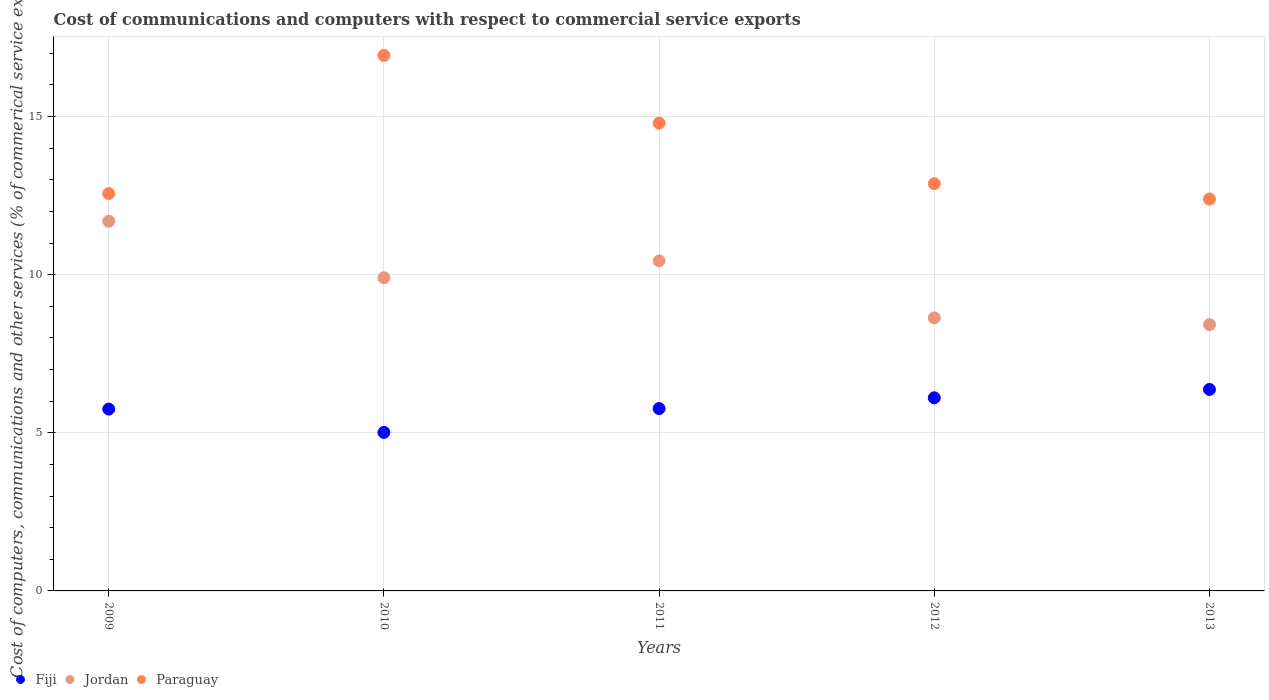Is the number of dotlines equal to the number of legend labels?
Your answer should be compact. Yes. What is the cost of communications and computers in Paraguay in 2009?
Keep it short and to the point. 12.56. Across all years, what is the maximum cost of communications and computers in Fiji?
Keep it short and to the point. 6.37. Across all years, what is the minimum cost of communications and computers in Fiji?
Make the answer very short. 5.01. In which year was the cost of communications and computers in Fiji maximum?
Make the answer very short. 2013. What is the total cost of communications and computers in Paraguay in the graph?
Offer a terse response. 69.56. What is the difference between the cost of communications and computers in Jordan in 2010 and that in 2011?
Make the answer very short. -0.53. What is the difference between the cost of communications and computers in Fiji in 2011 and the cost of communications and computers in Jordan in 2010?
Your answer should be compact. -4.14. What is the average cost of communications and computers in Fiji per year?
Make the answer very short. 5.8. In the year 2010, what is the difference between the cost of communications and computers in Paraguay and cost of communications and computers in Jordan?
Offer a terse response. 7.03. What is the ratio of the cost of communications and computers in Fiji in 2010 to that in 2013?
Your response must be concise. 0.79. Is the cost of communications and computers in Jordan in 2012 less than that in 2013?
Offer a terse response. No. Is the difference between the cost of communications and computers in Paraguay in 2010 and 2012 greater than the difference between the cost of communications and computers in Jordan in 2010 and 2012?
Your answer should be compact. Yes. What is the difference between the highest and the second highest cost of communications and computers in Paraguay?
Your answer should be compact. 2.14. What is the difference between the highest and the lowest cost of communications and computers in Fiji?
Your answer should be compact. 1.36. In how many years, is the cost of communications and computers in Fiji greater than the average cost of communications and computers in Fiji taken over all years?
Keep it short and to the point. 2. Is it the case that in every year, the sum of the cost of communications and computers in Paraguay and cost of communications and computers in Fiji  is greater than the cost of communications and computers in Jordan?
Offer a terse response. Yes. Is the cost of communications and computers in Paraguay strictly less than the cost of communications and computers in Jordan over the years?
Offer a very short reply. No. What is the difference between two consecutive major ticks on the Y-axis?
Ensure brevity in your answer.  5. Are the values on the major ticks of Y-axis written in scientific E-notation?
Make the answer very short. No. Does the graph contain grids?
Your answer should be very brief. Yes. Where does the legend appear in the graph?
Your answer should be very brief. Bottom left. How many legend labels are there?
Your answer should be very brief. 3. What is the title of the graph?
Provide a short and direct response. Cost of communications and computers with respect to commercial service exports. Does "Niger" appear as one of the legend labels in the graph?
Offer a terse response. No. What is the label or title of the X-axis?
Offer a terse response. Years. What is the label or title of the Y-axis?
Offer a very short reply. Cost of computers, communications and other services (% of commerical service exports). What is the Cost of computers, communications and other services (% of commerical service exports) of Fiji in 2009?
Your answer should be very brief. 5.75. What is the Cost of computers, communications and other services (% of commerical service exports) in Jordan in 2009?
Provide a short and direct response. 11.69. What is the Cost of computers, communications and other services (% of commerical service exports) in Paraguay in 2009?
Provide a succinct answer. 12.56. What is the Cost of computers, communications and other services (% of commerical service exports) of Fiji in 2010?
Your response must be concise. 5.01. What is the Cost of computers, communications and other services (% of commerical service exports) in Jordan in 2010?
Keep it short and to the point. 9.9. What is the Cost of computers, communications and other services (% of commerical service exports) in Paraguay in 2010?
Provide a succinct answer. 16.93. What is the Cost of computers, communications and other services (% of commerical service exports) in Fiji in 2011?
Offer a very short reply. 5.77. What is the Cost of computers, communications and other services (% of commerical service exports) in Jordan in 2011?
Ensure brevity in your answer.  10.44. What is the Cost of computers, communications and other services (% of commerical service exports) in Paraguay in 2011?
Give a very brief answer. 14.79. What is the Cost of computers, communications and other services (% of commerical service exports) of Fiji in 2012?
Your response must be concise. 6.11. What is the Cost of computers, communications and other services (% of commerical service exports) in Jordan in 2012?
Make the answer very short. 8.63. What is the Cost of computers, communications and other services (% of commerical service exports) in Paraguay in 2012?
Your response must be concise. 12.88. What is the Cost of computers, communications and other services (% of commerical service exports) of Fiji in 2013?
Give a very brief answer. 6.37. What is the Cost of computers, communications and other services (% of commerical service exports) in Jordan in 2013?
Give a very brief answer. 8.42. What is the Cost of computers, communications and other services (% of commerical service exports) in Paraguay in 2013?
Offer a very short reply. 12.39. Across all years, what is the maximum Cost of computers, communications and other services (% of commerical service exports) of Fiji?
Your response must be concise. 6.37. Across all years, what is the maximum Cost of computers, communications and other services (% of commerical service exports) of Jordan?
Your answer should be very brief. 11.69. Across all years, what is the maximum Cost of computers, communications and other services (% of commerical service exports) of Paraguay?
Give a very brief answer. 16.93. Across all years, what is the minimum Cost of computers, communications and other services (% of commerical service exports) in Fiji?
Ensure brevity in your answer.  5.01. Across all years, what is the minimum Cost of computers, communications and other services (% of commerical service exports) of Jordan?
Keep it short and to the point. 8.42. Across all years, what is the minimum Cost of computers, communications and other services (% of commerical service exports) of Paraguay?
Your answer should be very brief. 12.39. What is the total Cost of computers, communications and other services (% of commerical service exports) in Fiji in the graph?
Keep it short and to the point. 29.01. What is the total Cost of computers, communications and other services (% of commerical service exports) in Jordan in the graph?
Give a very brief answer. 49.08. What is the total Cost of computers, communications and other services (% of commerical service exports) of Paraguay in the graph?
Give a very brief answer. 69.56. What is the difference between the Cost of computers, communications and other services (% of commerical service exports) of Fiji in 2009 and that in 2010?
Give a very brief answer. 0.74. What is the difference between the Cost of computers, communications and other services (% of commerical service exports) in Jordan in 2009 and that in 2010?
Your answer should be very brief. 1.79. What is the difference between the Cost of computers, communications and other services (% of commerical service exports) in Paraguay in 2009 and that in 2010?
Give a very brief answer. -4.37. What is the difference between the Cost of computers, communications and other services (% of commerical service exports) of Fiji in 2009 and that in 2011?
Your answer should be compact. -0.02. What is the difference between the Cost of computers, communications and other services (% of commerical service exports) of Jordan in 2009 and that in 2011?
Provide a succinct answer. 1.25. What is the difference between the Cost of computers, communications and other services (% of commerical service exports) in Paraguay in 2009 and that in 2011?
Ensure brevity in your answer.  -2.23. What is the difference between the Cost of computers, communications and other services (% of commerical service exports) of Fiji in 2009 and that in 2012?
Keep it short and to the point. -0.36. What is the difference between the Cost of computers, communications and other services (% of commerical service exports) in Jordan in 2009 and that in 2012?
Offer a terse response. 3.06. What is the difference between the Cost of computers, communications and other services (% of commerical service exports) in Paraguay in 2009 and that in 2012?
Offer a very short reply. -0.31. What is the difference between the Cost of computers, communications and other services (% of commerical service exports) in Fiji in 2009 and that in 2013?
Your answer should be compact. -0.62. What is the difference between the Cost of computers, communications and other services (% of commerical service exports) in Jordan in 2009 and that in 2013?
Your response must be concise. 3.27. What is the difference between the Cost of computers, communications and other services (% of commerical service exports) of Paraguay in 2009 and that in 2013?
Your answer should be compact. 0.17. What is the difference between the Cost of computers, communications and other services (% of commerical service exports) of Fiji in 2010 and that in 2011?
Your answer should be compact. -0.76. What is the difference between the Cost of computers, communications and other services (% of commerical service exports) in Jordan in 2010 and that in 2011?
Keep it short and to the point. -0.53. What is the difference between the Cost of computers, communications and other services (% of commerical service exports) in Paraguay in 2010 and that in 2011?
Provide a short and direct response. 2.14. What is the difference between the Cost of computers, communications and other services (% of commerical service exports) of Fiji in 2010 and that in 2012?
Offer a very short reply. -1.1. What is the difference between the Cost of computers, communications and other services (% of commerical service exports) in Jordan in 2010 and that in 2012?
Offer a terse response. 1.27. What is the difference between the Cost of computers, communications and other services (% of commerical service exports) in Paraguay in 2010 and that in 2012?
Keep it short and to the point. 4.06. What is the difference between the Cost of computers, communications and other services (% of commerical service exports) of Fiji in 2010 and that in 2013?
Your response must be concise. -1.36. What is the difference between the Cost of computers, communications and other services (% of commerical service exports) in Jordan in 2010 and that in 2013?
Ensure brevity in your answer.  1.48. What is the difference between the Cost of computers, communications and other services (% of commerical service exports) of Paraguay in 2010 and that in 2013?
Provide a short and direct response. 4.54. What is the difference between the Cost of computers, communications and other services (% of commerical service exports) of Fiji in 2011 and that in 2012?
Provide a succinct answer. -0.34. What is the difference between the Cost of computers, communications and other services (% of commerical service exports) of Jordan in 2011 and that in 2012?
Give a very brief answer. 1.8. What is the difference between the Cost of computers, communications and other services (% of commerical service exports) in Paraguay in 2011 and that in 2012?
Your response must be concise. 1.91. What is the difference between the Cost of computers, communications and other services (% of commerical service exports) in Fiji in 2011 and that in 2013?
Your answer should be very brief. -0.6. What is the difference between the Cost of computers, communications and other services (% of commerical service exports) in Jordan in 2011 and that in 2013?
Ensure brevity in your answer.  2.02. What is the difference between the Cost of computers, communications and other services (% of commerical service exports) of Paraguay in 2011 and that in 2013?
Your answer should be very brief. 2.4. What is the difference between the Cost of computers, communications and other services (% of commerical service exports) in Fiji in 2012 and that in 2013?
Provide a short and direct response. -0.26. What is the difference between the Cost of computers, communications and other services (% of commerical service exports) in Jordan in 2012 and that in 2013?
Offer a very short reply. 0.21. What is the difference between the Cost of computers, communications and other services (% of commerical service exports) in Paraguay in 2012 and that in 2013?
Offer a very short reply. 0.48. What is the difference between the Cost of computers, communications and other services (% of commerical service exports) in Fiji in 2009 and the Cost of computers, communications and other services (% of commerical service exports) in Jordan in 2010?
Keep it short and to the point. -4.15. What is the difference between the Cost of computers, communications and other services (% of commerical service exports) of Fiji in 2009 and the Cost of computers, communications and other services (% of commerical service exports) of Paraguay in 2010?
Provide a short and direct response. -11.18. What is the difference between the Cost of computers, communications and other services (% of commerical service exports) of Jordan in 2009 and the Cost of computers, communications and other services (% of commerical service exports) of Paraguay in 2010?
Ensure brevity in your answer.  -5.24. What is the difference between the Cost of computers, communications and other services (% of commerical service exports) of Fiji in 2009 and the Cost of computers, communications and other services (% of commerical service exports) of Jordan in 2011?
Offer a very short reply. -4.69. What is the difference between the Cost of computers, communications and other services (% of commerical service exports) of Fiji in 2009 and the Cost of computers, communications and other services (% of commerical service exports) of Paraguay in 2011?
Your answer should be compact. -9.04. What is the difference between the Cost of computers, communications and other services (% of commerical service exports) in Jordan in 2009 and the Cost of computers, communications and other services (% of commerical service exports) in Paraguay in 2011?
Provide a short and direct response. -3.1. What is the difference between the Cost of computers, communications and other services (% of commerical service exports) in Fiji in 2009 and the Cost of computers, communications and other services (% of commerical service exports) in Jordan in 2012?
Offer a very short reply. -2.88. What is the difference between the Cost of computers, communications and other services (% of commerical service exports) in Fiji in 2009 and the Cost of computers, communications and other services (% of commerical service exports) in Paraguay in 2012?
Make the answer very short. -7.13. What is the difference between the Cost of computers, communications and other services (% of commerical service exports) in Jordan in 2009 and the Cost of computers, communications and other services (% of commerical service exports) in Paraguay in 2012?
Offer a very short reply. -1.19. What is the difference between the Cost of computers, communications and other services (% of commerical service exports) in Fiji in 2009 and the Cost of computers, communications and other services (% of commerical service exports) in Jordan in 2013?
Offer a terse response. -2.67. What is the difference between the Cost of computers, communications and other services (% of commerical service exports) of Fiji in 2009 and the Cost of computers, communications and other services (% of commerical service exports) of Paraguay in 2013?
Offer a terse response. -6.64. What is the difference between the Cost of computers, communications and other services (% of commerical service exports) in Jordan in 2009 and the Cost of computers, communications and other services (% of commerical service exports) in Paraguay in 2013?
Your answer should be very brief. -0.7. What is the difference between the Cost of computers, communications and other services (% of commerical service exports) in Fiji in 2010 and the Cost of computers, communications and other services (% of commerical service exports) in Jordan in 2011?
Provide a short and direct response. -5.42. What is the difference between the Cost of computers, communications and other services (% of commerical service exports) of Fiji in 2010 and the Cost of computers, communications and other services (% of commerical service exports) of Paraguay in 2011?
Your response must be concise. -9.78. What is the difference between the Cost of computers, communications and other services (% of commerical service exports) of Jordan in 2010 and the Cost of computers, communications and other services (% of commerical service exports) of Paraguay in 2011?
Offer a very short reply. -4.89. What is the difference between the Cost of computers, communications and other services (% of commerical service exports) of Fiji in 2010 and the Cost of computers, communications and other services (% of commerical service exports) of Jordan in 2012?
Offer a terse response. -3.62. What is the difference between the Cost of computers, communications and other services (% of commerical service exports) in Fiji in 2010 and the Cost of computers, communications and other services (% of commerical service exports) in Paraguay in 2012?
Your answer should be compact. -7.86. What is the difference between the Cost of computers, communications and other services (% of commerical service exports) in Jordan in 2010 and the Cost of computers, communications and other services (% of commerical service exports) in Paraguay in 2012?
Your answer should be compact. -2.97. What is the difference between the Cost of computers, communications and other services (% of commerical service exports) in Fiji in 2010 and the Cost of computers, communications and other services (% of commerical service exports) in Jordan in 2013?
Provide a short and direct response. -3.41. What is the difference between the Cost of computers, communications and other services (% of commerical service exports) of Fiji in 2010 and the Cost of computers, communications and other services (% of commerical service exports) of Paraguay in 2013?
Provide a short and direct response. -7.38. What is the difference between the Cost of computers, communications and other services (% of commerical service exports) of Jordan in 2010 and the Cost of computers, communications and other services (% of commerical service exports) of Paraguay in 2013?
Offer a very short reply. -2.49. What is the difference between the Cost of computers, communications and other services (% of commerical service exports) in Fiji in 2011 and the Cost of computers, communications and other services (% of commerical service exports) in Jordan in 2012?
Keep it short and to the point. -2.87. What is the difference between the Cost of computers, communications and other services (% of commerical service exports) in Fiji in 2011 and the Cost of computers, communications and other services (% of commerical service exports) in Paraguay in 2012?
Your response must be concise. -7.11. What is the difference between the Cost of computers, communications and other services (% of commerical service exports) of Jordan in 2011 and the Cost of computers, communications and other services (% of commerical service exports) of Paraguay in 2012?
Give a very brief answer. -2.44. What is the difference between the Cost of computers, communications and other services (% of commerical service exports) of Fiji in 2011 and the Cost of computers, communications and other services (% of commerical service exports) of Jordan in 2013?
Provide a succinct answer. -2.65. What is the difference between the Cost of computers, communications and other services (% of commerical service exports) in Fiji in 2011 and the Cost of computers, communications and other services (% of commerical service exports) in Paraguay in 2013?
Your answer should be very brief. -6.63. What is the difference between the Cost of computers, communications and other services (% of commerical service exports) in Jordan in 2011 and the Cost of computers, communications and other services (% of commerical service exports) in Paraguay in 2013?
Offer a very short reply. -1.96. What is the difference between the Cost of computers, communications and other services (% of commerical service exports) of Fiji in 2012 and the Cost of computers, communications and other services (% of commerical service exports) of Jordan in 2013?
Offer a very short reply. -2.31. What is the difference between the Cost of computers, communications and other services (% of commerical service exports) in Fiji in 2012 and the Cost of computers, communications and other services (% of commerical service exports) in Paraguay in 2013?
Your answer should be compact. -6.29. What is the difference between the Cost of computers, communications and other services (% of commerical service exports) in Jordan in 2012 and the Cost of computers, communications and other services (% of commerical service exports) in Paraguay in 2013?
Provide a succinct answer. -3.76. What is the average Cost of computers, communications and other services (% of commerical service exports) of Fiji per year?
Your answer should be compact. 5.8. What is the average Cost of computers, communications and other services (% of commerical service exports) of Jordan per year?
Keep it short and to the point. 9.82. What is the average Cost of computers, communications and other services (% of commerical service exports) in Paraguay per year?
Keep it short and to the point. 13.91. In the year 2009, what is the difference between the Cost of computers, communications and other services (% of commerical service exports) in Fiji and Cost of computers, communications and other services (% of commerical service exports) in Jordan?
Provide a short and direct response. -5.94. In the year 2009, what is the difference between the Cost of computers, communications and other services (% of commerical service exports) of Fiji and Cost of computers, communications and other services (% of commerical service exports) of Paraguay?
Your answer should be compact. -6.82. In the year 2009, what is the difference between the Cost of computers, communications and other services (% of commerical service exports) in Jordan and Cost of computers, communications and other services (% of commerical service exports) in Paraguay?
Your answer should be compact. -0.88. In the year 2010, what is the difference between the Cost of computers, communications and other services (% of commerical service exports) in Fiji and Cost of computers, communications and other services (% of commerical service exports) in Jordan?
Keep it short and to the point. -4.89. In the year 2010, what is the difference between the Cost of computers, communications and other services (% of commerical service exports) in Fiji and Cost of computers, communications and other services (% of commerical service exports) in Paraguay?
Your response must be concise. -11.92. In the year 2010, what is the difference between the Cost of computers, communications and other services (% of commerical service exports) of Jordan and Cost of computers, communications and other services (% of commerical service exports) of Paraguay?
Provide a succinct answer. -7.03. In the year 2011, what is the difference between the Cost of computers, communications and other services (% of commerical service exports) of Fiji and Cost of computers, communications and other services (% of commerical service exports) of Jordan?
Make the answer very short. -4.67. In the year 2011, what is the difference between the Cost of computers, communications and other services (% of commerical service exports) in Fiji and Cost of computers, communications and other services (% of commerical service exports) in Paraguay?
Make the answer very short. -9.02. In the year 2011, what is the difference between the Cost of computers, communications and other services (% of commerical service exports) in Jordan and Cost of computers, communications and other services (% of commerical service exports) in Paraguay?
Your response must be concise. -4.36. In the year 2012, what is the difference between the Cost of computers, communications and other services (% of commerical service exports) in Fiji and Cost of computers, communications and other services (% of commerical service exports) in Jordan?
Keep it short and to the point. -2.53. In the year 2012, what is the difference between the Cost of computers, communications and other services (% of commerical service exports) of Fiji and Cost of computers, communications and other services (% of commerical service exports) of Paraguay?
Keep it short and to the point. -6.77. In the year 2012, what is the difference between the Cost of computers, communications and other services (% of commerical service exports) in Jordan and Cost of computers, communications and other services (% of commerical service exports) in Paraguay?
Your answer should be compact. -4.24. In the year 2013, what is the difference between the Cost of computers, communications and other services (% of commerical service exports) in Fiji and Cost of computers, communications and other services (% of commerical service exports) in Jordan?
Give a very brief answer. -2.05. In the year 2013, what is the difference between the Cost of computers, communications and other services (% of commerical service exports) of Fiji and Cost of computers, communications and other services (% of commerical service exports) of Paraguay?
Your answer should be compact. -6.02. In the year 2013, what is the difference between the Cost of computers, communications and other services (% of commerical service exports) of Jordan and Cost of computers, communications and other services (% of commerical service exports) of Paraguay?
Ensure brevity in your answer.  -3.97. What is the ratio of the Cost of computers, communications and other services (% of commerical service exports) of Fiji in 2009 to that in 2010?
Offer a terse response. 1.15. What is the ratio of the Cost of computers, communications and other services (% of commerical service exports) in Jordan in 2009 to that in 2010?
Make the answer very short. 1.18. What is the ratio of the Cost of computers, communications and other services (% of commerical service exports) of Paraguay in 2009 to that in 2010?
Ensure brevity in your answer.  0.74. What is the ratio of the Cost of computers, communications and other services (% of commerical service exports) in Jordan in 2009 to that in 2011?
Provide a short and direct response. 1.12. What is the ratio of the Cost of computers, communications and other services (% of commerical service exports) of Paraguay in 2009 to that in 2011?
Offer a terse response. 0.85. What is the ratio of the Cost of computers, communications and other services (% of commerical service exports) in Fiji in 2009 to that in 2012?
Provide a short and direct response. 0.94. What is the ratio of the Cost of computers, communications and other services (% of commerical service exports) of Jordan in 2009 to that in 2012?
Provide a short and direct response. 1.35. What is the ratio of the Cost of computers, communications and other services (% of commerical service exports) in Paraguay in 2009 to that in 2012?
Give a very brief answer. 0.98. What is the ratio of the Cost of computers, communications and other services (% of commerical service exports) of Fiji in 2009 to that in 2013?
Offer a terse response. 0.9. What is the ratio of the Cost of computers, communications and other services (% of commerical service exports) of Jordan in 2009 to that in 2013?
Offer a terse response. 1.39. What is the ratio of the Cost of computers, communications and other services (% of commerical service exports) in Paraguay in 2009 to that in 2013?
Give a very brief answer. 1.01. What is the ratio of the Cost of computers, communications and other services (% of commerical service exports) in Fiji in 2010 to that in 2011?
Keep it short and to the point. 0.87. What is the ratio of the Cost of computers, communications and other services (% of commerical service exports) in Jordan in 2010 to that in 2011?
Your answer should be compact. 0.95. What is the ratio of the Cost of computers, communications and other services (% of commerical service exports) of Paraguay in 2010 to that in 2011?
Give a very brief answer. 1.14. What is the ratio of the Cost of computers, communications and other services (% of commerical service exports) in Fiji in 2010 to that in 2012?
Offer a terse response. 0.82. What is the ratio of the Cost of computers, communications and other services (% of commerical service exports) of Jordan in 2010 to that in 2012?
Provide a short and direct response. 1.15. What is the ratio of the Cost of computers, communications and other services (% of commerical service exports) of Paraguay in 2010 to that in 2012?
Provide a succinct answer. 1.31. What is the ratio of the Cost of computers, communications and other services (% of commerical service exports) in Fiji in 2010 to that in 2013?
Your answer should be very brief. 0.79. What is the ratio of the Cost of computers, communications and other services (% of commerical service exports) in Jordan in 2010 to that in 2013?
Your answer should be very brief. 1.18. What is the ratio of the Cost of computers, communications and other services (% of commerical service exports) in Paraguay in 2010 to that in 2013?
Keep it short and to the point. 1.37. What is the ratio of the Cost of computers, communications and other services (% of commerical service exports) of Fiji in 2011 to that in 2012?
Provide a short and direct response. 0.94. What is the ratio of the Cost of computers, communications and other services (% of commerical service exports) in Jordan in 2011 to that in 2012?
Your answer should be very brief. 1.21. What is the ratio of the Cost of computers, communications and other services (% of commerical service exports) in Paraguay in 2011 to that in 2012?
Your response must be concise. 1.15. What is the ratio of the Cost of computers, communications and other services (% of commerical service exports) of Fiji in 2011 to that in 2013?
Offer a terse response. 0.91. What is the ratio of the Cost of computers, communications and other services (% of commerical service exports) of Jordan in 2011 to that in 2013?
Offer a terse response. 1.24. What is the ratio of the Cost of computers, communications and other services (% of commerical service exports) of Paraguay in 2011 to that in 2013?
Your answer should be compact. 1.19. What is the ratio of the Cost of computers, communications and other services (% of commerical service exports) of Fiji in 2012 to that in 2013?
Make the answer very short. 0.96. What is the ratio of the Cost of computers, communications and other services (% of commerical service exports) in Jordan in 2012 to that in 2013?
Your answer should be compact. 1.03. What is the ratio of the Cost of computers, communications and other services (% of commerical service exports) in Paraguay in 2012 to that in 2013?
Make the answer very short. 1.04. What is the difference between the highest and the second highest Cost of computers, communications and other services (% of commerical service exports) of Fiji?
Your answer should be very brief. 0.26. What is the difference between the highest and the second highest Cost of computers, communications and other services (% of commerical service exports) of Jordan?
Give a very brief answer. 1.25. What is the difference between the highest and the second highest Cost of computers, communications and other services (% of commerical service exports) in Paraguay?
Your answer should be compact. 2.14. What is the difference between the highest and the lowest Cost of computers, communications and other services (% of commerical service exports) of Fiji?
Make the answer very short. 1.36. What is the difference between the highest and the lowest Cost of computers, communications and other services (% of commerical service exports) of Jordan?
Offer a very short reply. 3.27. What is the difference between the highest and the lowest Cost of computers, communications and other services (% of commerical service exports) of Paraguay?
Your answer should be very brief. 4.54. 